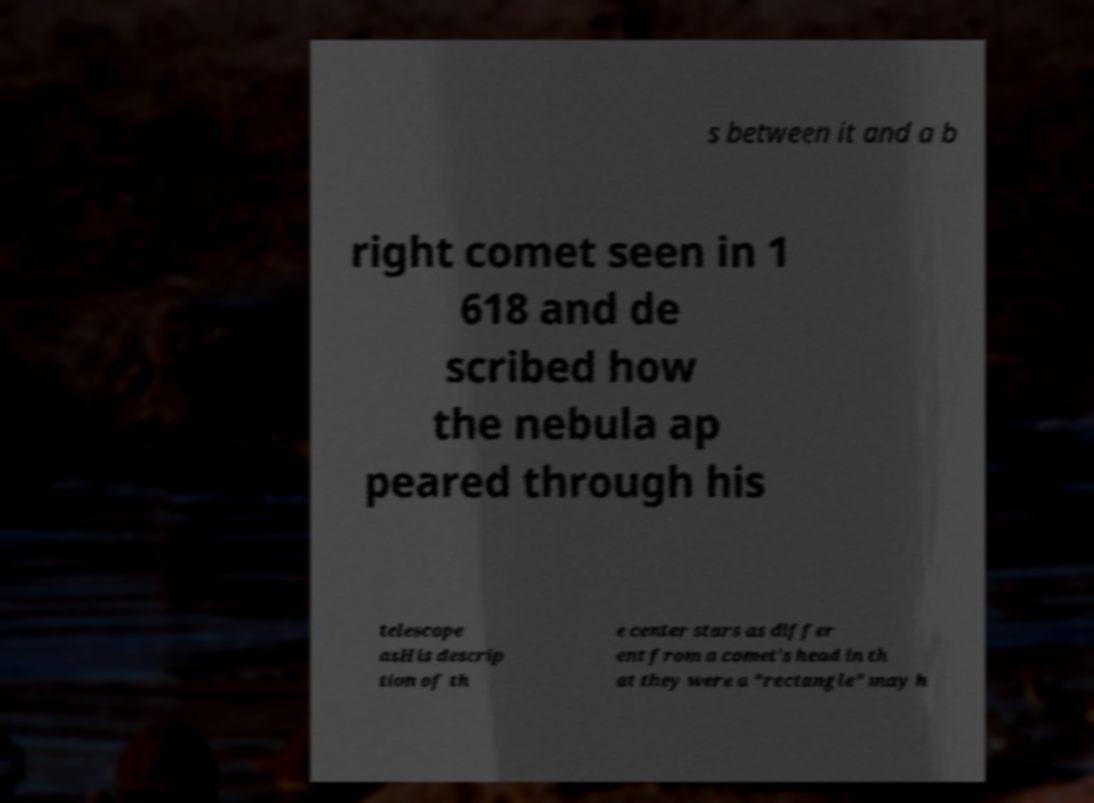What messages or text are displayed in this image? I need them in a readable, typed format. s between it and a b right comet seen in 1 618 and de scribed how the nebula ap peared through his telescope asHis descrip tion of th e center stars as differ ent from a comet's head in th at they were a "rectangle" may h 